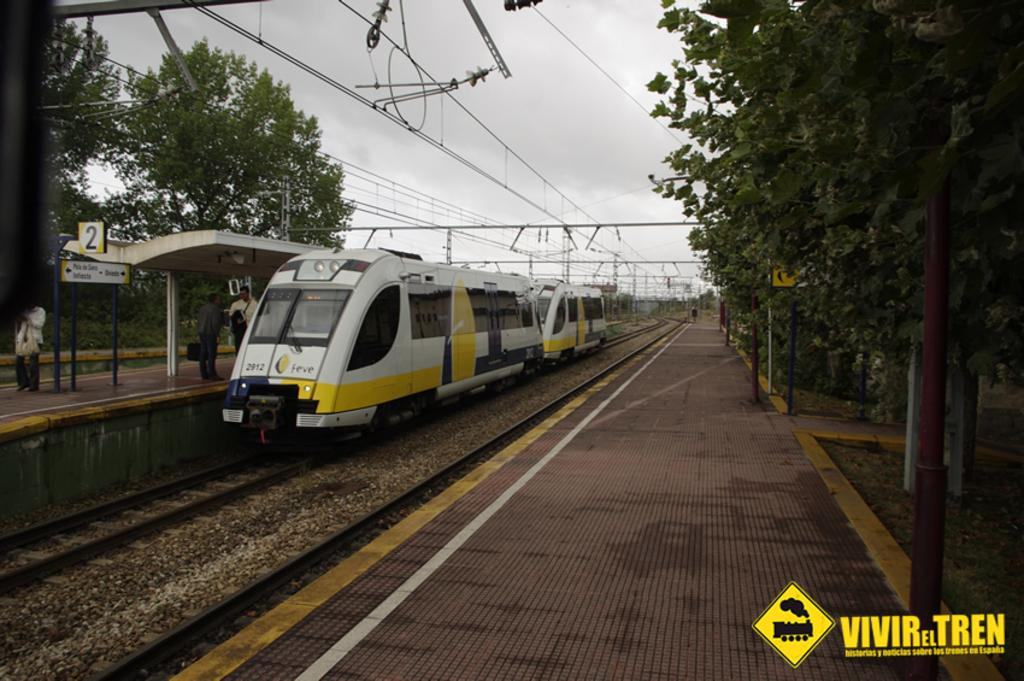<image>
Describe the image concisely. a train that is neat a vivir tren ad 